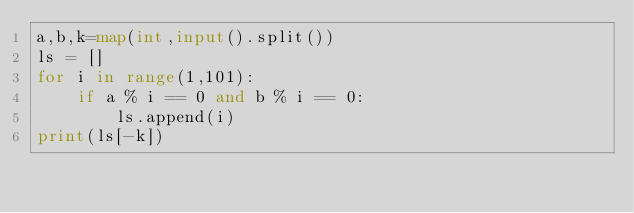Convert code to text. <code><loc_0><loc_0><loc_500><loc_500><_Python_>a,b,k=map(int,input().split())
ls = []
for i in range(1,101):
    if a % i == 0 and b % i == 0:
        ls.append(i)
print(ls[-k])</code> 